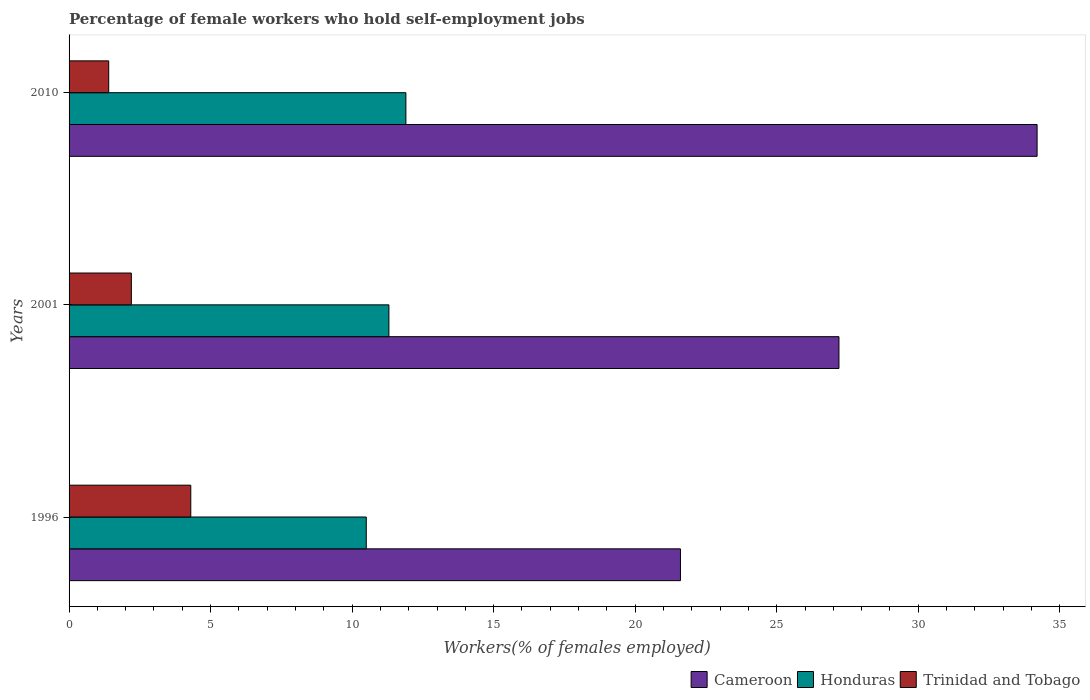How many groups of bars are there?
Your answer should be compact. 3. Are the number of bars per tick equal to the number of legend labels?
Offer a terse response. Yes. How many bars are there on the 1st tick from the top?
Offer a terse response. 3. What is the label of the 1st group of bars from the top?
Provide a succinct answer. 2010. In how many cases, is the number of bars for a given year not equal to the number of legend labels?
Your answer should be compact. 0. What is the percentage of self-employed female workers in Honduras in 2010?
Give a very brief answer. 11.9. Across all years, what is the maximum percentage of self-employed female workers in Honduras?
Your response must be concise. 11.9. Across all years, what is the minimum percentage of self-employed female workers in Cameroon?
Your answer should be compact. 21.6. In which year was the percentage of self-employed female workers in Trinidad and Tobago maximum?
Your answer should be very brief. 1996. In which year was the percentage of self-employed female workers in Cameroon minimum?
Provide a short and direct response. 1996. What is the total percentage of self-employed female workers in Trinidad and Tobago in the graph?
Make the answer very short. 7.9. What is the difference between the percentage of self-employed female workers in Honduras in 1996 and that in 2001?
Offer a terse response. -0.8. What is the difference between the percentage of self-employed female workers in Honduras in 1996 and the percentage of self-employed female workers in Cameroon in 2001?
Make the answer very short. -16.7. What is the average percentage of self-employed female workers in Trinidad and Tobago per year?
Offer a very short reply. 2.63. In the year 1996, what is the difference between the percentage of self-employed female workers in Trinidad and Tobago and percentage of self-employed female workers in Cameroon?
Give a very brief answer. -17.3. What is the ratio of the percentage of self-employed female workers in Cameroon in 1996 to that in 2010?
Give a very brief answer. 0.63. What is the difference between the highest and the second highest percentage of self-employed female workers in Honduras?
Give a very brief answer. 0.6. What is the difference between the highest and the lowest percentage of self-employed female workers in Trinidad and Tobago?
Your answer should be very brief. 2.9. In how many years, is the percentage of self-employed female workers in Trinidad and Tobago greater than the average percentage of self-employed female workers in Trinidad and Tobago taken over all years?
Your answer should be compact. 1. What does the 2nd bar from the top in 1996 represents?
Give a very brief answer. Honduras. What does the 2nd bar from the bottom in 2010 represents?
Provide a short and direct response. Honduras. How many bars are there?
Give a very brief answer. 9. Are all the bars in the graph horizontal?
Offer a very short reply. Yes. How many years are there in the graph?
Give a very brief answer. 3. Where does the legend appear in the graph?
Give a very brief answer. Bottom right. How are the legend labels stacked?
Ensure brevity in your answer.  Horizontal. What is the title of the graph?
Offer a terse response. Percentage of female workers who hold self-employment jobs. Does "Tonga" appear as one of the legend labels in the graph?
Ensure brevity in your answer.  No. What is the label or title of the X-axis?
Ensure brevity in your answer.  Workers(% of females employed). What is the Workers(% of females employed) of Cameroon in 1996?
Your response must be concise. 21.6. What is the Workers(% of females employed) of Honduras in 1996?
Offer a very short reply. 10.5. What is the Workers(% of females employed) of Trinidad and Tobago in 1996?
Offer a very short reply. 4.3. What is the Workers(% of females employed) in Cameroon in 2001?
Offer a very short reply. 27.2. What is the Workers(% of females employed) in Honduras in 2001?
Offer a terse response. 11.3. What is the Workers(% of females employed) in Trinidad and Tobago in 2001?
Keep it short and to the point. 2.2. What is the Workers(% of females employed) in Cameroon in 2010?
Your answer should be very brief. 34.2. What is the Workers(% of females employed) of Honduras in 2010?
Your answer should be compact. 11.9. What is the Workers(% of females employed) of Trinidad and Tobago in 2010?
Your answer should be compact. 1.4. Across all years, what is the maximum Workers(% of females employed) in Cameroon?
Provide a succinct answer. 34.2. Across all years, what is the maximum Workers(% of females employed) of Honduras?
Offer a terse response. 11.9. Across all years, what is the maximum Workers(% of females employed) in Trinidad and Tobago?
Provide a succinct answer. 4.3. Across all years, what is the minimum Workers(% of females employed) in Cameroon?
Your response must be concise. 21.6. Across all years, what is the minimum Workers(% of females employed) of Honduras?
Make the answer very short. 10.5. Across all years, what is the minimum Workers(% of females employed) of Trinidad and Tobago?
Provide a short and direct response. 1.4. What is the total Workers(% of females employed) in Honduras in the graph?
Keep it short and to the point. 33.7. What is the total Workers(% of females employed) in Trinidad and Tobago in the graph?
Ensure brevity in your answer.  7.9. What is the difference between the Workers(% of females employed) in Cameroon in 1996 and that in 2001?
Offer a very short reply. -5.6. What is the difference between the Workers(% of females employed) of Cameroon in 1996 and that in 2010?
Offer a terse response. -12.6. What is the difference between the Workers(% of females employed) of Honduras in 1996 and that in 2010?
Provide a short and direct response. -1.4. What is the difference between the Workers(% of females employed) of Honduras in 2001 and that in 2010?
Provide a short and direct response. -0.6. What is the difference between the Workers(% of females employed) in Cameroon in 1996 and the Workers(% of females employed) in Trinidad and Tobago in 2010?
Ensure brevity in your answer.  20.2. What is the difference between the Workers(% of females employed) of Honduras in 1996 and the Workers(% of females employed) of Trinidad and Tobago in 2010?
Ensure brevity in your answer.  9.1. What is the difference between the Workers(% of females employed) of Cameroon in 2001 and the Workers(% of females employed) of Trinidad and Tobago in 2010?
Keep it short and to the point. 25.8. What is the average Workers(% of females employed) in Cameroon per year?
Provide a short and direct response. 27.67. What is the average Workers(% of females employed) of Honduras per year?
Your answer should be compact. 11.23. What is the average Workers(% of females employed) of Trinidad and Tobago per year?
Ensure brevity in your answer.  2.63. In the year 1996, what is the difference between the Workers(% of females employed) in Cameroon and Workers(% of females employed) in Honduras?
Give a very brief answer. 11.1. In the year 1996, what is the difference between the Workers(% of females employed) in Honduras and Workers(% of females employed) in Trinidad and Tobago?
Your answer should be very brief. 6.2. In the year 2001, what is the difference between the Workers(% of females employed) of Honduras and Workers(% of females employed) of Trinidad and Tobago?
Keep it short and to the point. 9.1. In the year 2010, what is the difference between the Workers(% of females employed) of Cameroon and Workers(% of females employed) of Honduras?
Your answer should be compact. 22.3. In the year 2010, what is the difference between the Workers(% of females employed) in Cameroon and Workers(% of females employed) in Trinidad and Tobago?
Your response must be concise. 32.8. In the year 2010, what is the difference between the Workers(% of females employed) in Honduras and Workers(% of females employed) in Trinidad and Tobago?
Make the answer very short. 10.5. What is the ratio of the Workers(% of females employed) of Cameroon in 1996 to that in 2001?
Keep it short and to the point. 0.79. What is the ratio of the Workers(% of females employed) of Honduras in 1996 to that in 2001?
Make the answer very short. 0.93. What is the ratio of the Workers(% of females employed) in Trinidad and Tobago in 1996 to that in 2001?
Provide a short and direct response. 1.95. What is the ratio of the Workers(% of females employed) in Cameroon in 1996 to that in 2010?
Your answer should be very brief. 0.63. What is the ratio of the Workers(% of females employed) of Honduras in 1996 to that in 2010?
Make the answer very short. 0.88. What is the ratio of the Workers(% of females employed) in Trinidad and Tobago in 1996 to that in 2010?
Keep it short and to the point. 3.07. What is the ratio of the Workers(% of females employed) of Cameroon in 2001 to that in 2010?
Provide a short and direct response. 0.8. What is the ratio of the Workers(% of females employed) of Honduras in 2001 to that in 2010?
Your answer should be compact. 0.95. What is the ratio of the Workers(% of females employed) of Trinidad and Tobago in 2001 to that in 2010?
Provide a short and direct response. 1.57. What is the difference between the highest and the second highest Workers(% of females employed) of Cameroon?
Ensure brevity in your answer.  7. What is the difference between the highest and the second highest Workers(% of females employed) in Honduras?
Give a very brief answer. 0.6. What is the difference between the highest and the lowest Workers(% of females employed) in Cameroon?
Offer a very short reply. 12.6. What is the difference between the highest and the lowest Workers(% of females employed) in Honduras?
Provide a short and direct response. 1.4. What is the difference between the highest and the lowest Workers(% of females employed) of Trinidad and Tobago?
Make the answer very short. 2.9. 